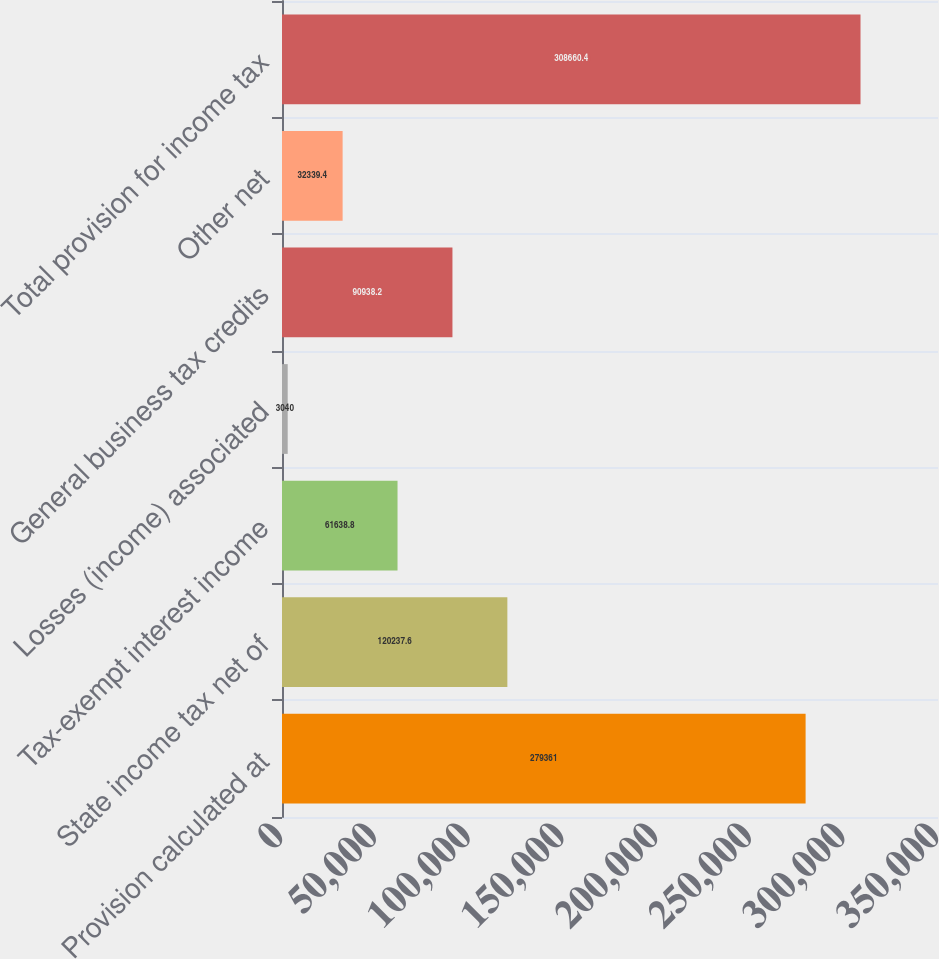<chart> <loc_0><loc_0><loc_500><loc_500><bar_chart><fcel>Provision calculated at<fcel>State income tax net of<fcel>Tax-exempt interest income<fcel>Losses (income) associated<fcel>General business tax credits<fcel>Other net<fcel>Total provision for income tax<nl><fcel>279361<fcel>120238<fcel>61638.8<fcel>3040<fcel>90938.2<fcel>32339.4<fcel>308660<nl></chart> 